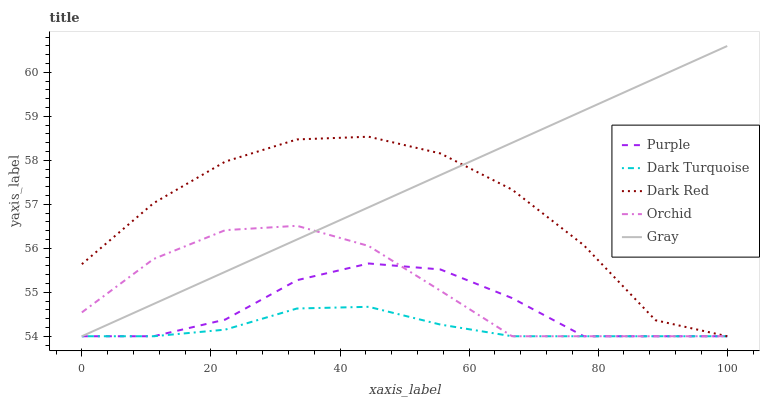Does Gray have the minimum area under the curve?
Answer yes or no. No. Does Dark Turquoise have the maximum area under the curve?
Answer yes or no. No. Is Dark Turquoise the smoothest?
Answer yes or no. No. Is Dark Turquoise the roughest?
Answer yes or no. No. Does Dark Turquoise have the highest value?
Answer yes or no. No. 